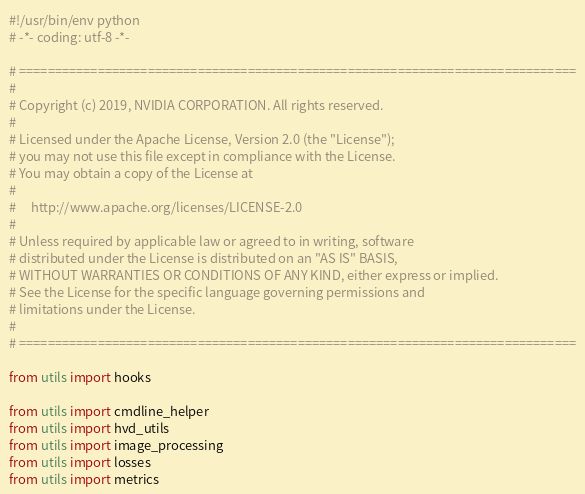<code> <loc_0><loc_0><loc_500><loc_500><_Python_>#!/usr/bin/env python
# -*- coding: utf-8 -*-

# ==============================================================================
#
# Copyright (c) 2019, NVIDIA CORPORATION. All rights reserved.
#
# Licensed under the Apache License, Version 2.0 (the "License");
# you may not use this file except in compliance with the License.
# You may obtain a copy of the License at
#
#     http://www.apache.org/licenses/LICENSE-2.0
#
# Unless required by applicable law or agreed to in writing, software
# distributed under the License is distributed on an "AS IS" BASIS,
# WITHOUT WARRANTIES OR CONDITIONS OF ANY KIND, either express or implied.
# See the License for the specific language governing permissions and
# limitations under the License.
#
# ==============================================================================

from utils import hooks

from utils import cmdline_helper
from utils import hvd_utils
from utils import image_processing
from utils import losses
from utils import metrics
</code> 